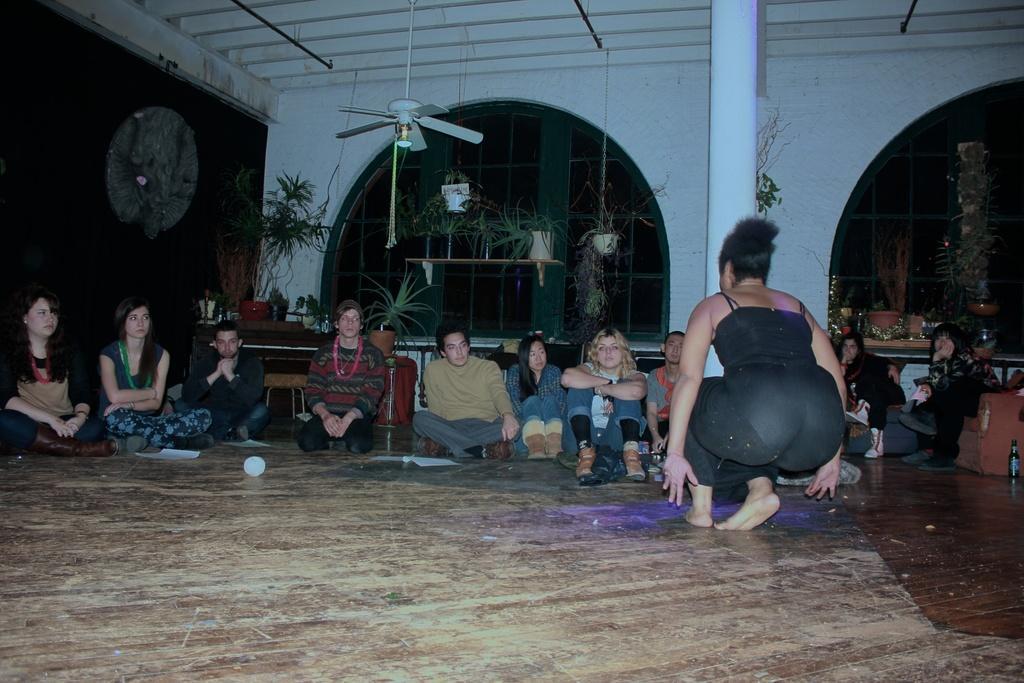Describe this image in one or two sentences. In this picture I can see some people are sitting and one woman is in a squat position. In the background I can see a fan, white color pillar and plant pots. On the right side I can see bottle and other objects on the floor. 